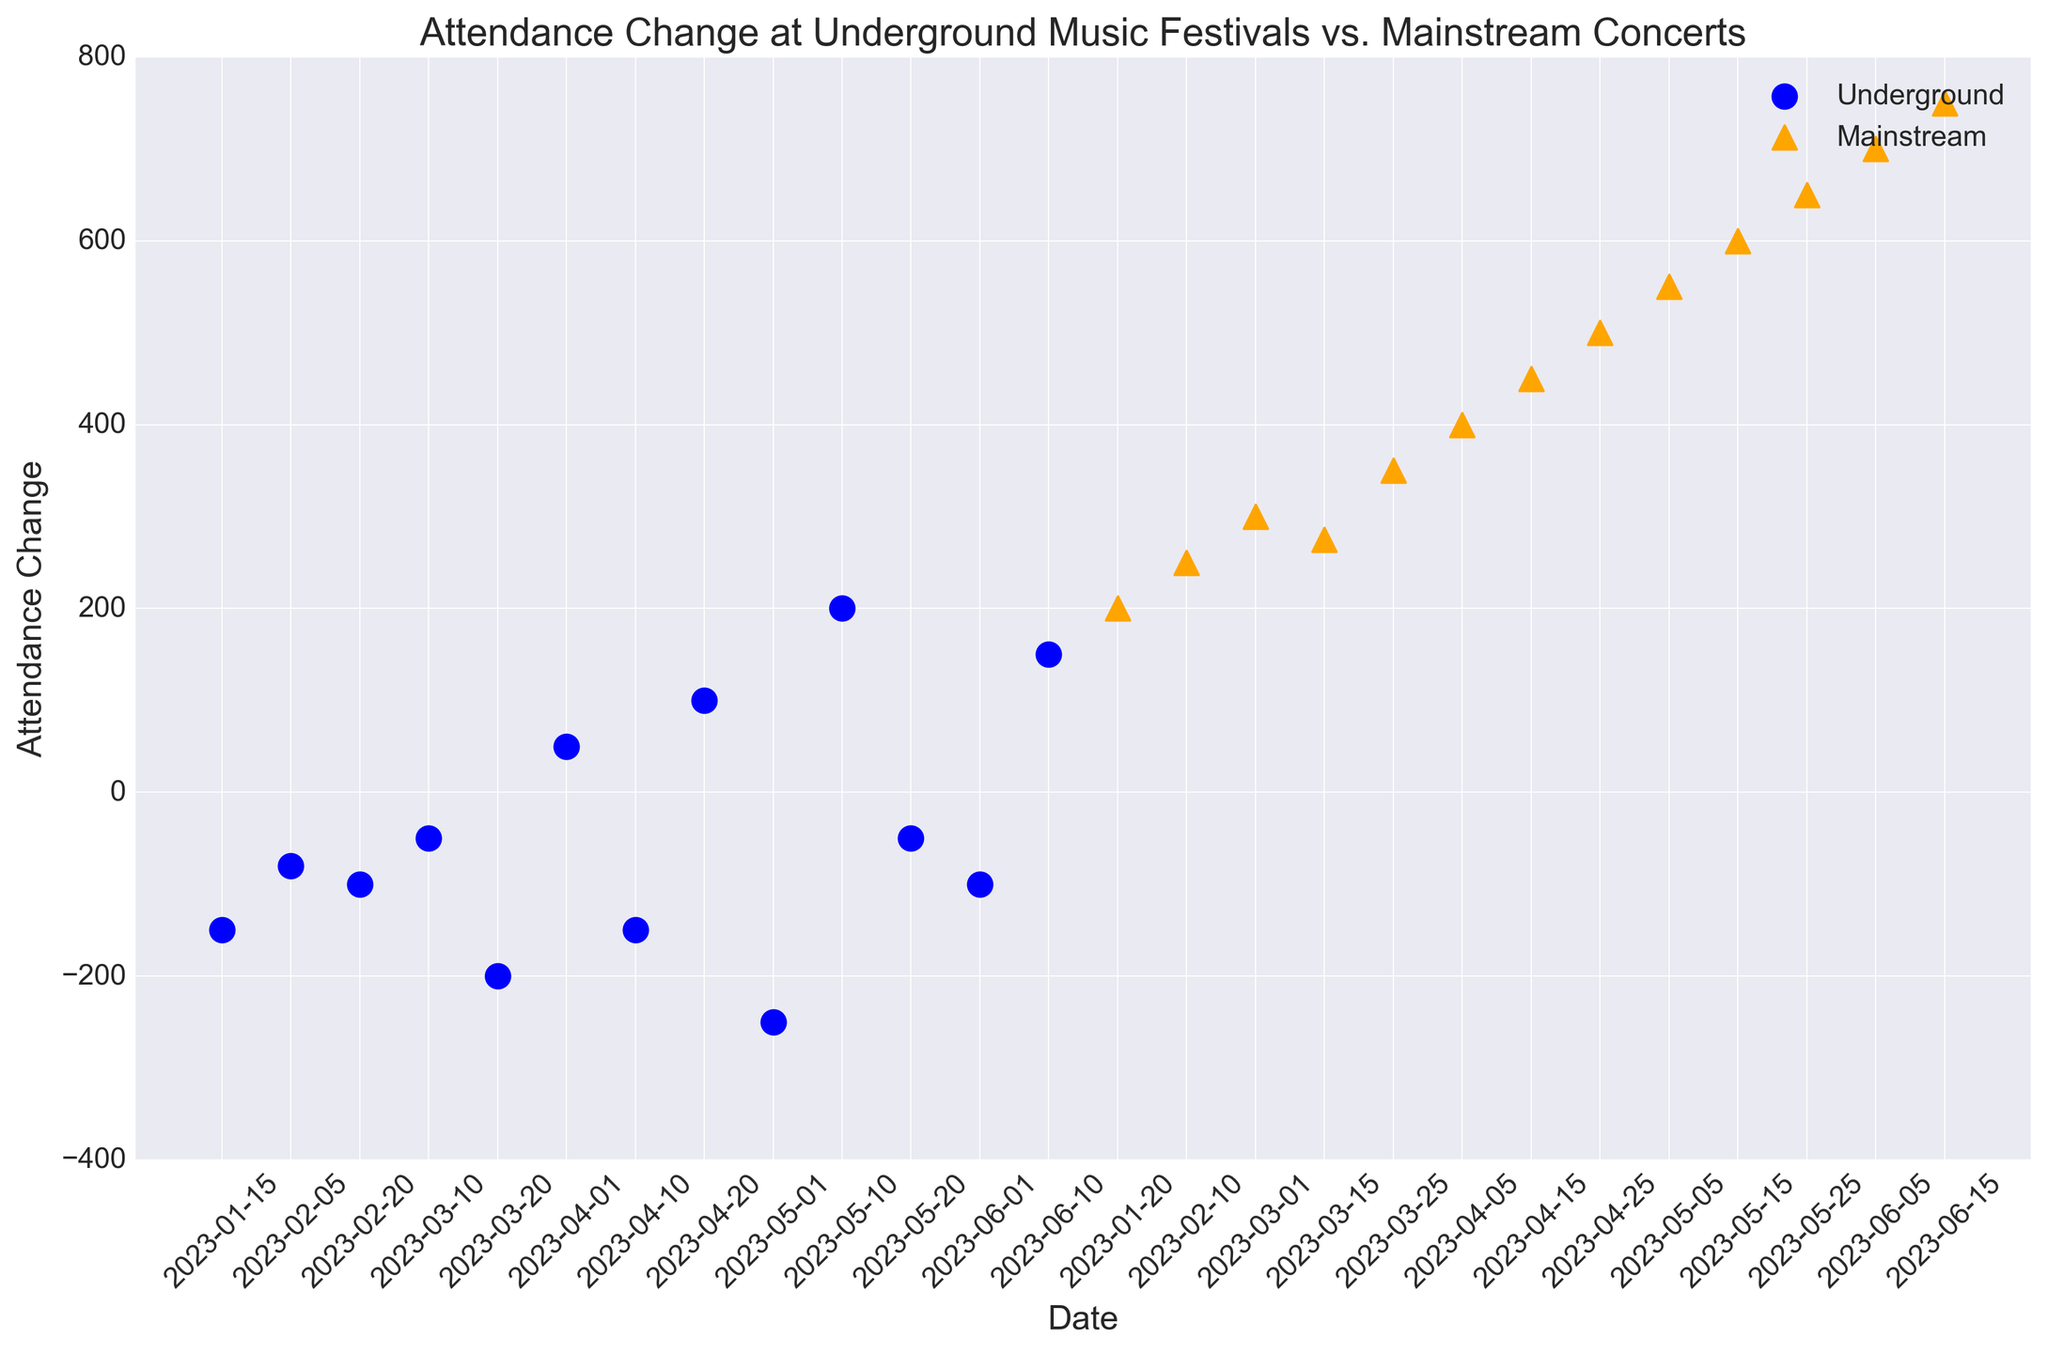What are the dates when the attendance change for underground events was positive? Look at the plot for blue circles above the zero line. The dates corresponding to these points are 2023-04-01, 2023-04-20, 2023-05-10, and 2023-06-10.
Answer: 2023-04-01, 2023-04-20, 2023-05-10, 2023-06-10 Which event type generally shows higher attendance changes? Compare the visual placements of blue circles and orange triangles. The orange triangles (representing mainstream events) are generally higher than blue circles (representing underground events).
Answer: Mainstream By how much does the highest attendance change in underground events differ from the lowest? The highest attendance change in underground events is +200, and the lowest is -250. The difference is 200 - (-250) = 450.
Answer: 450 Which date experienced the largest decrease in attendance for underground events, and what was the change? Identify the blue circle that is the lowest on the y-axis. The date corresponding to this point is 2023-05-01 with an attendance change of -250.
Answer: 2023-05-01, -250 Between March 10 and April 10, what is the overall trend in attendance changes for mainstream events? Look at the orange triangles between these dates. They are located progressively higher, indicating an increasing trend in attendance.
Answer: Increasing trend What's the difference in attendance change between the first and last mainstream event? The first mainstream event on 2023-01-20 has a change of +200, and the last on 2023-06-15 is +750. The difference is 750 - 200 = 550.
Answer: 550 How many times did the underground events have negative attendance changes? Count the number of blue circles below the zero line. There are eight dates with negative attendance changes.
Answer: 8 What is the attendance change difference between the highest mainstream event and the lowest underground event? The highest mainstream event has an attendance change of +750, and the lowest underground event is -250. The difference is 750 - (-250) = 1000.
Answer: 1000 Which month has the most significant difference in attendance change between underground and mainstream events? Compare the monthly pairs of blue circles and orange triangles, noting the vertical difference. April shows the largest difference, with +500 for mainstream and -150 to +100 for underground events, making the maximum difference 500 - (-150) = 650.
Answer: April How does the attendance change vary over time for underground events as compared to mainstream events? Visually compare the scatter plots' trends. Underground events (blue circles) show fluctuations with mostly negative changes with a few positive spikes, while mainstream events (orange triangles) show a consistent increase over time.
Answer: Underground: Fluctuating, mostly negative; Mainstream: Consistently increasing 